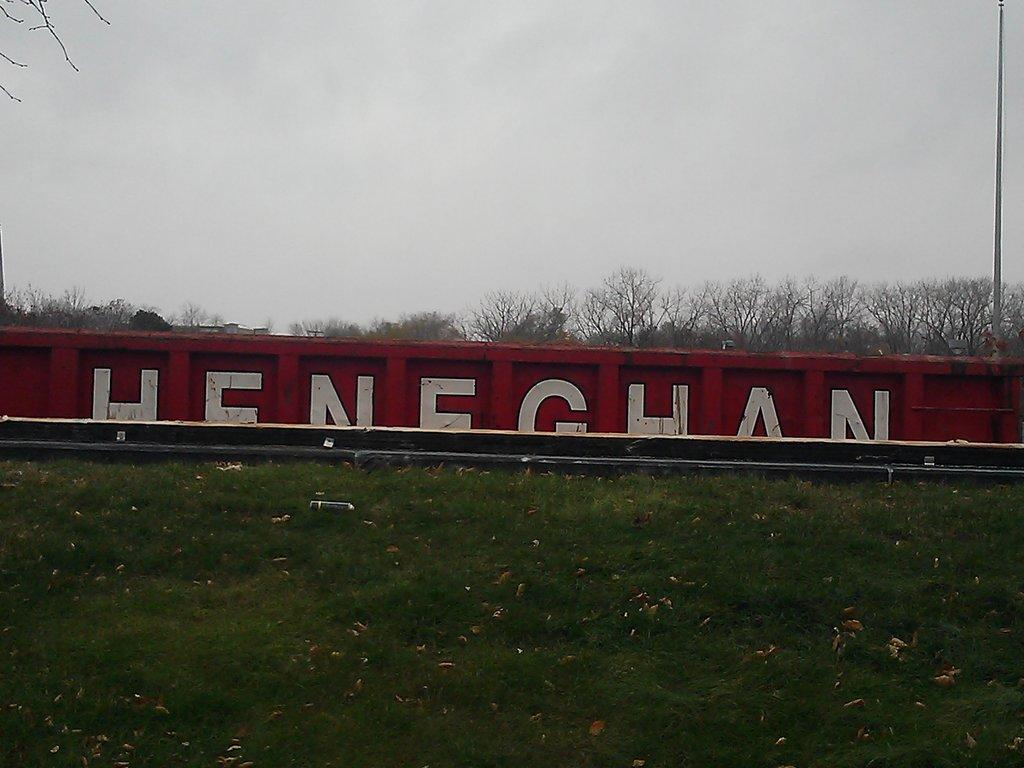<image>
Describe the image concisely. Red container which says HENEGHAN on it behind some grass. 